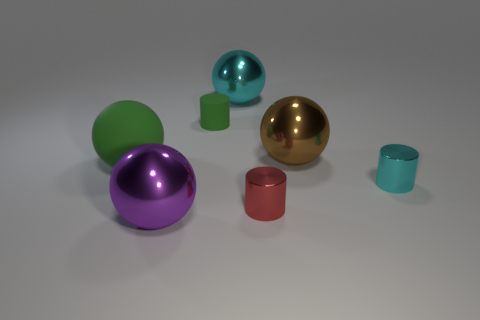What is the material of the big green sphere?
Provide a succinct answer. Rubber. What is the tiny cylinder that is to the right of the metal cylinder that is to the left of the cyan shiny object that is right of the large cyan metal ball made of?
Make the answer very short. Metal. There is a big rubber ball; does it have the same color as the matte object that is to the right of the purple sphere?
Provide a succinct answer. Yes. Is there anything else that is the same shape as the tiny green matte object?
Offer a terse response. Yes. The matte object in front of the matte thing on the right side of the big purple ball is what color?
Your response must be concise. Green. How many tiny blue rubber things are there?
Ensure brevity in your answer.  0. How many matte objects are either things or large objects?
Ensure brevity in your answer.  2. What number of large spheres are the same color as the tiny matte cylinder?
Give a very brief answer. 1. There is a large cyan sphere that is behind the large shiny sphere that is to the left of the cyan sphere; what is its material?
Your answer should be very brief. Metal. What is the size of the red metallic cylinder?
Keep it short and to the point. Small. 